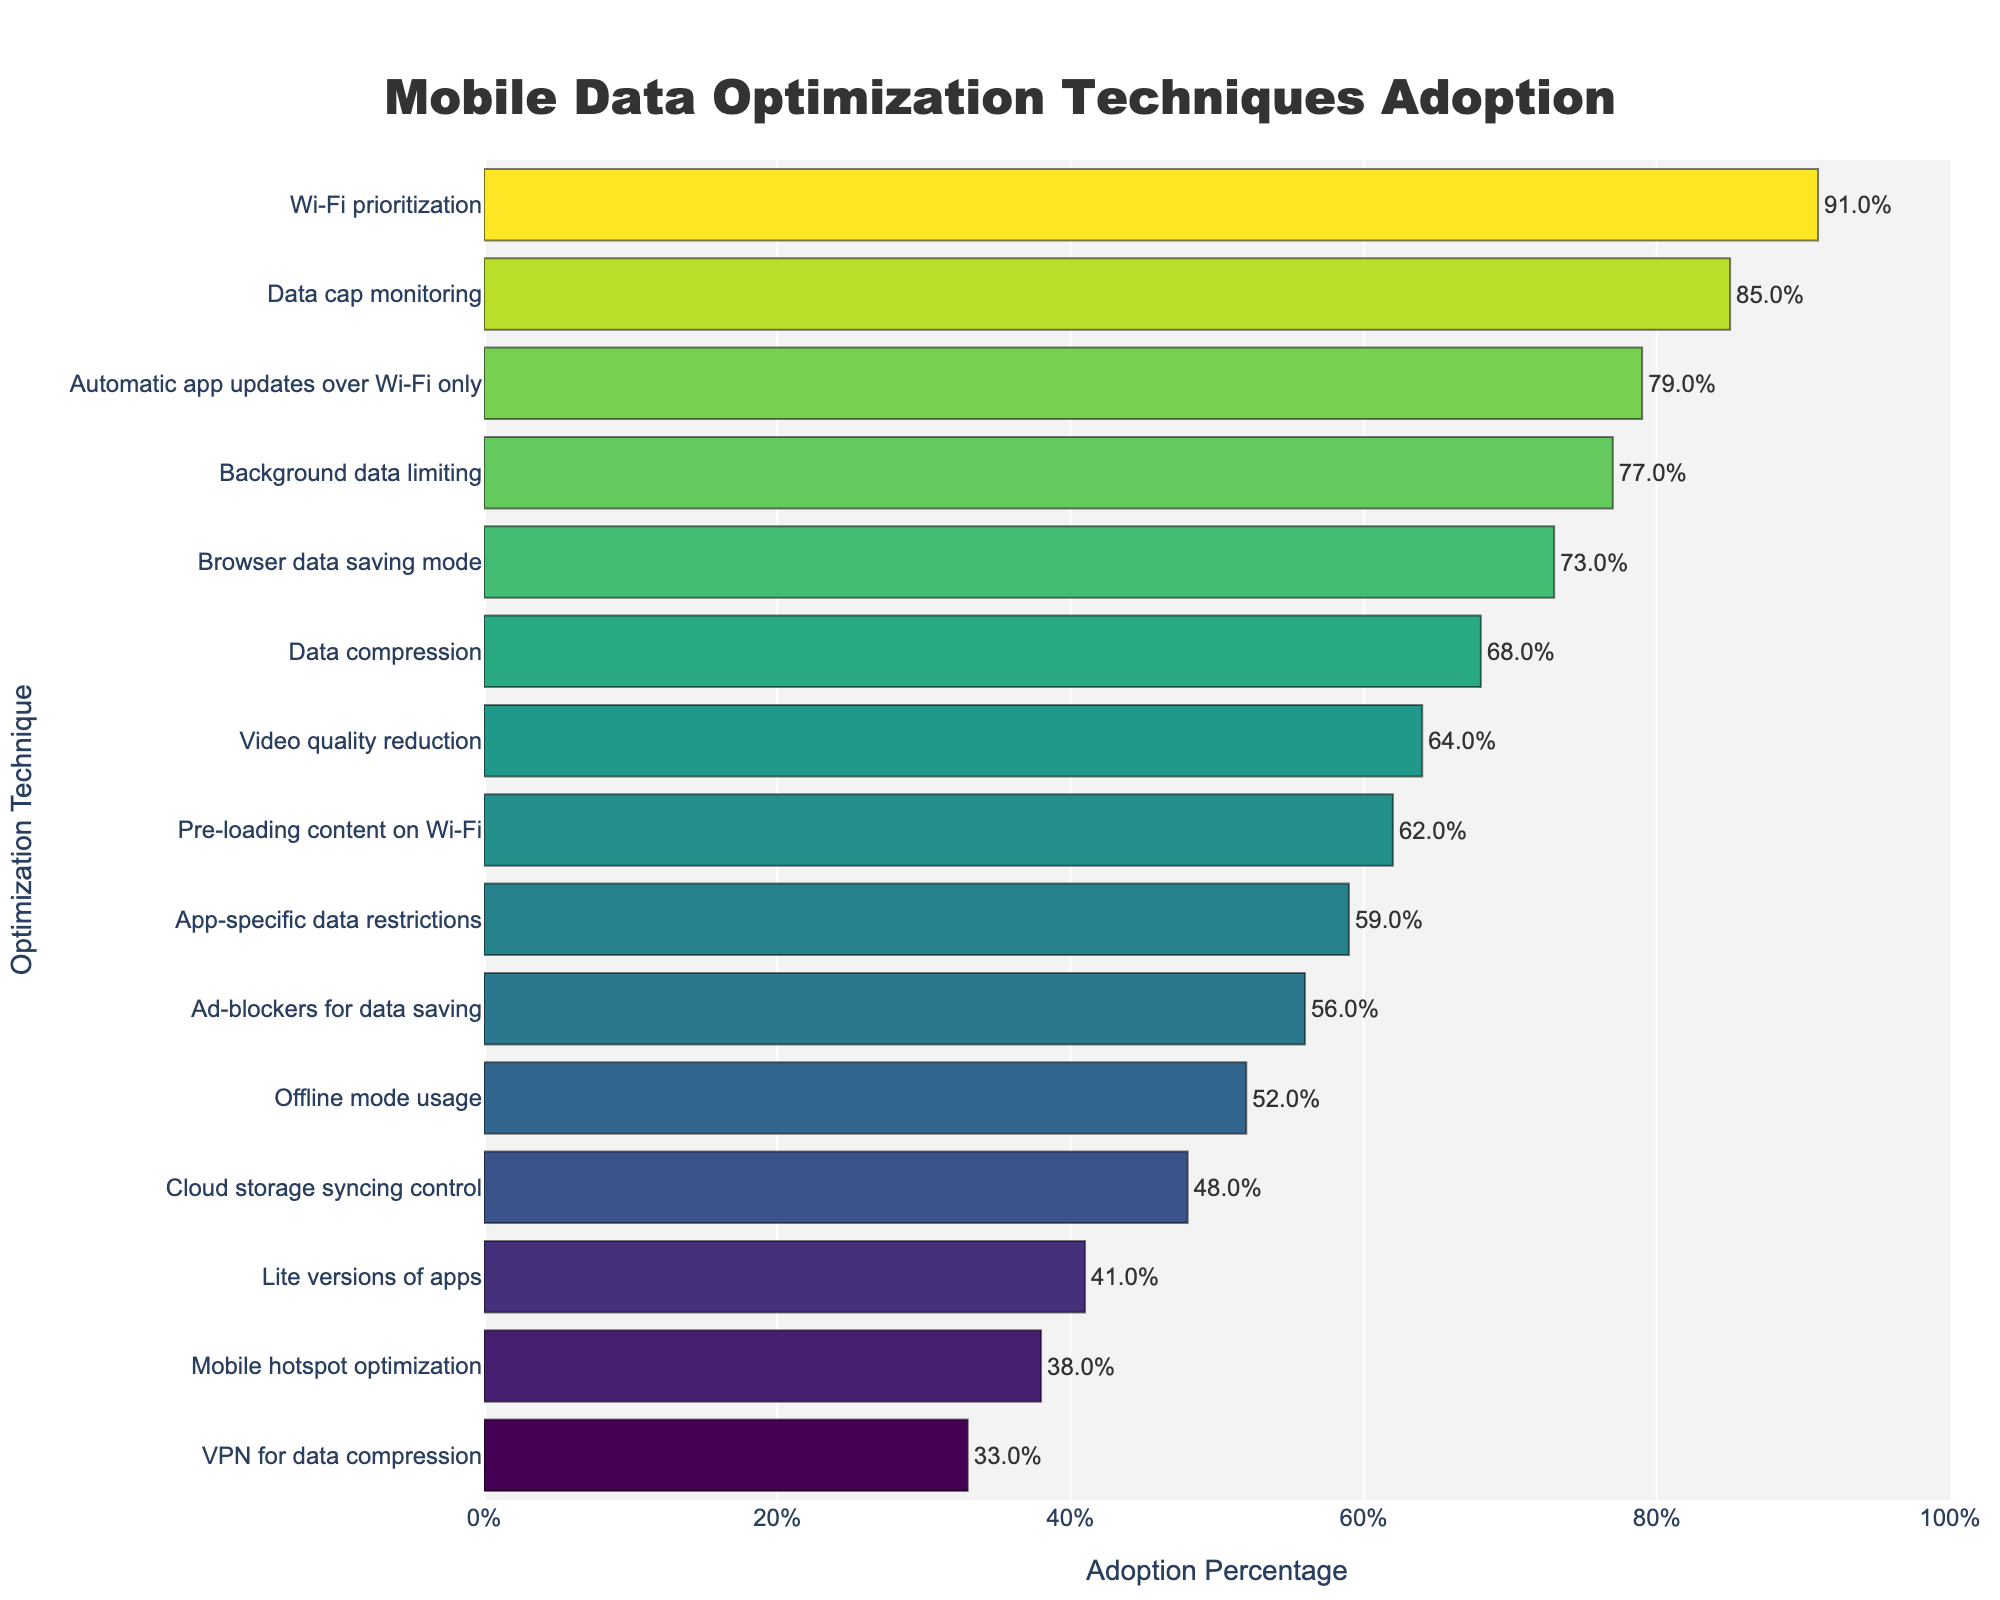Which data optimization technique is the most adopted? The bar corresponding to "Wi-Fi prioritization" extends the furthest to the right, indicating the highest percentage of adoption at 91%.
Answer: Wi-Fi prioritization Which technique is the least adopted? The bar for "VPN for data compression" is the shortest, representing the smallest adoption percentage at 33%.
Answer: VPN for data compression What is the difference in adoption percentage between "Data cap monitoring" and "Lite versions of apps"? "Data cap monitoring" has an adoption percentage of 85%, while "Lite versions of apps" have 41%. Subtracting 41 from 85 gives the difference.
Answer: 44% Which techniques have an adoption percentage greater than 70%? The bars for "Wi-Fi prioritization," "Data cap monitoring," "Browser data saving mode," "Background data limiting," and "Automatic app updates over Wi-Fi only" all extend beyond the 70% mark.
Answer: Wi-Fi prioritization, Data cap monitoring, Browser data saving mode, Background data limiting, Automatic app updates over Wi-Fi only Which techniques fall below the 50% adoption threshold? The bars for "Cloud storage syncing control," "Ad-blockers for data saving," "Lite versions of apps," "Mobile hotspot optimization," and "VPN for data compression" are all below 50%.
Answer: Cloud storage syncing control, Ad-blockers for data saving, Lite versions of apps, Mobile hotspot optimization, VPN for data compression Are there more techniques with adoption rates above 60% or below 60%? Techniques above 60%: Data compression, Data cap monitoring, Browser data saving mode, Background data limiting, Video quality reduction, Pre-loading content on Wi-Fi, Automatic app updates over Wi-Fi only, Wi-Fi prioritization (8 total). Techniques below 60%: Offline mode usage, App-specific data restrictions, Cloud storage syncing control, Ad-blockers for data saving, Lite versions of apps, Mobile hotspot optimization, VPN for data compression (7 total).
Answer: Above 60% What is the average adoption percentage for the techniques listed? Add all the percentages together: (68 + 52 + 85 + 73 + 91 + 59 + 77 + 64 + 48 + 56 + 41 + 62 + 79 + 38 + 33) = 926. Divide by the number of techniques: 926 / 15.
Answer: 61.73% Which technique lies at the median in terms of adoption? When sorted in descending order, the middle technique (8th position) is "Video quality reduction" with an adoption rate of 64%.
Answer: Video quality reduction How much higher is the adoption of "Background data limiting" compared to "Offline mode usage"? "Background data limiting" has a percentage of 77%, and "Offline mode usage" has 52%. Subtracting 52 from 77: 77 - 52.
Answer: 25% Is the adoption of "Pre-loading content on Wi-Fi" closer to "Video quality reduction" or "Automatic app updates over Wi-Fi only"? "Pre-loading content on Wi-Fi" is 62%, "Video quality reduction" is 64%, and "Automatic app updates over Wi-Fi only" is 79%. The difference between "Pre-loading content on Wi-Fi" and "Video quality reduction" is 2%, while it is 17% for "Automatic app updates over Wi-Fi only."
Answer: Video quality reduction 